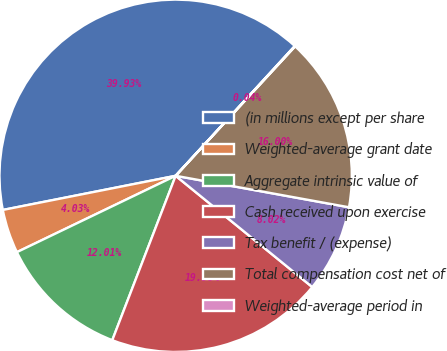<chart> <loc_0><loc_0><loc_500><loc_500><pie_chart><fcel>(in millions except per share<fcel>Weighted-average grant date<fcel>Aggregate intrinsic value of<fcel>Cash received upon exercise<fcel>Tax benefit / (expense)<fcel>Total compensation cost net of<fcel>Weighted-average period in<nl><fcel>39.93%<fcel>4.03%<fcel>12.01%<fcel>19.98%<fcel>8.02%<fcel>16.0%<fcel>0.04%<nl></chart> 